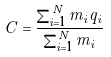<formula> <loc_0><loc_0><loc_500><loc_500>C = \frac { \sum _ { i = 1 } ^ { N } m _ { i } q _ { i } } { \sum _ { i = 1 } ^ { N } m _ { i } }</formula> 